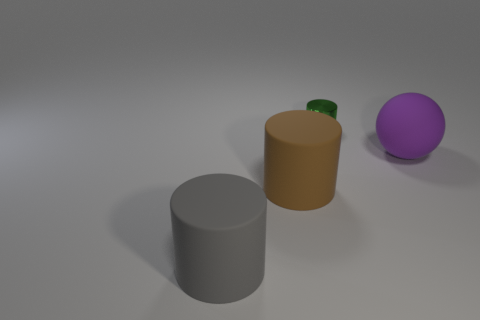Subtract 1 cylinders. How many cylinders are left? 2 Add 4 gray cubes. How many objects exist? 8 Subtract all cylinders. How many objects are left? 1 Subtract 0 blue cylinders. How many objects are left? 4 Subtract all small purple matte objects. Subtract all big gray cylinders. How many objects are left? 3 Add 2 tiny green shiny objects. How many tiny green shiny objects are left? 3 Add 1 small green cylinders. How many small green cylinders exist? 2 